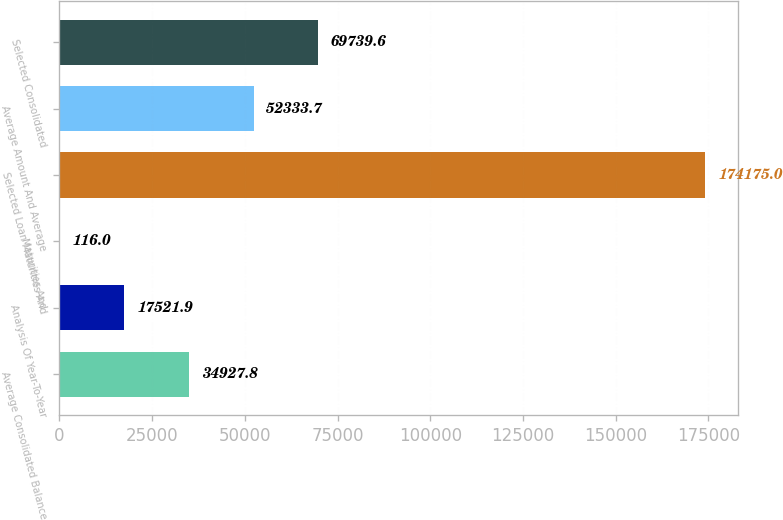Convert chart to OTSL. <chart><loc_0><loc_0><loc_500><loc_500><bar_chart><fcel>Average Consolidated Balance<fcel>Analysis Of Year-To-Year<fcel>Maturities And<fcel>Selected Loan Maturities And<fcel>Average Amount And Average<fcel>Selected Consolidated<nl><fcel>34927.8<fcel>17521.9<fcel>116<fcel>174175<fcel>52333.7<fcel>69739.6<nl></chart> 